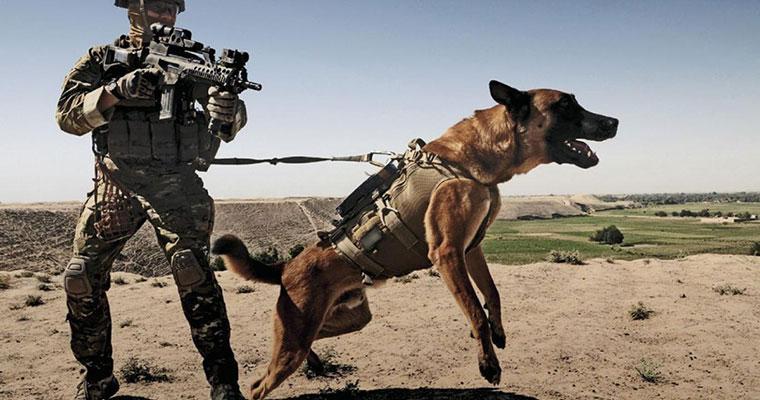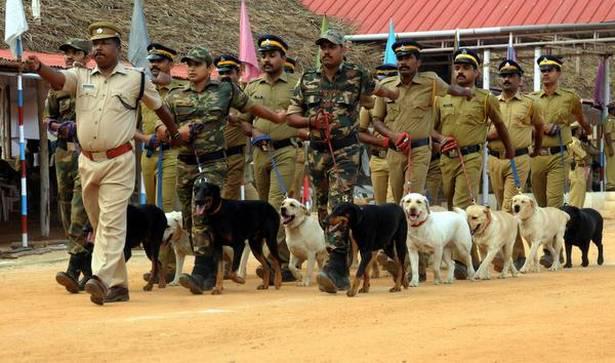The first image is the image on the left, the second image is the image on the right. Given the left and right images, does the statement "In one of the images, only one dog is present." hold true? Answer yes or no. Yes. The first image is the image on the left, the second image is the image on the right. For the images shown, is this caption "At least one dog is sitting." true? Answer yes or no. No. 